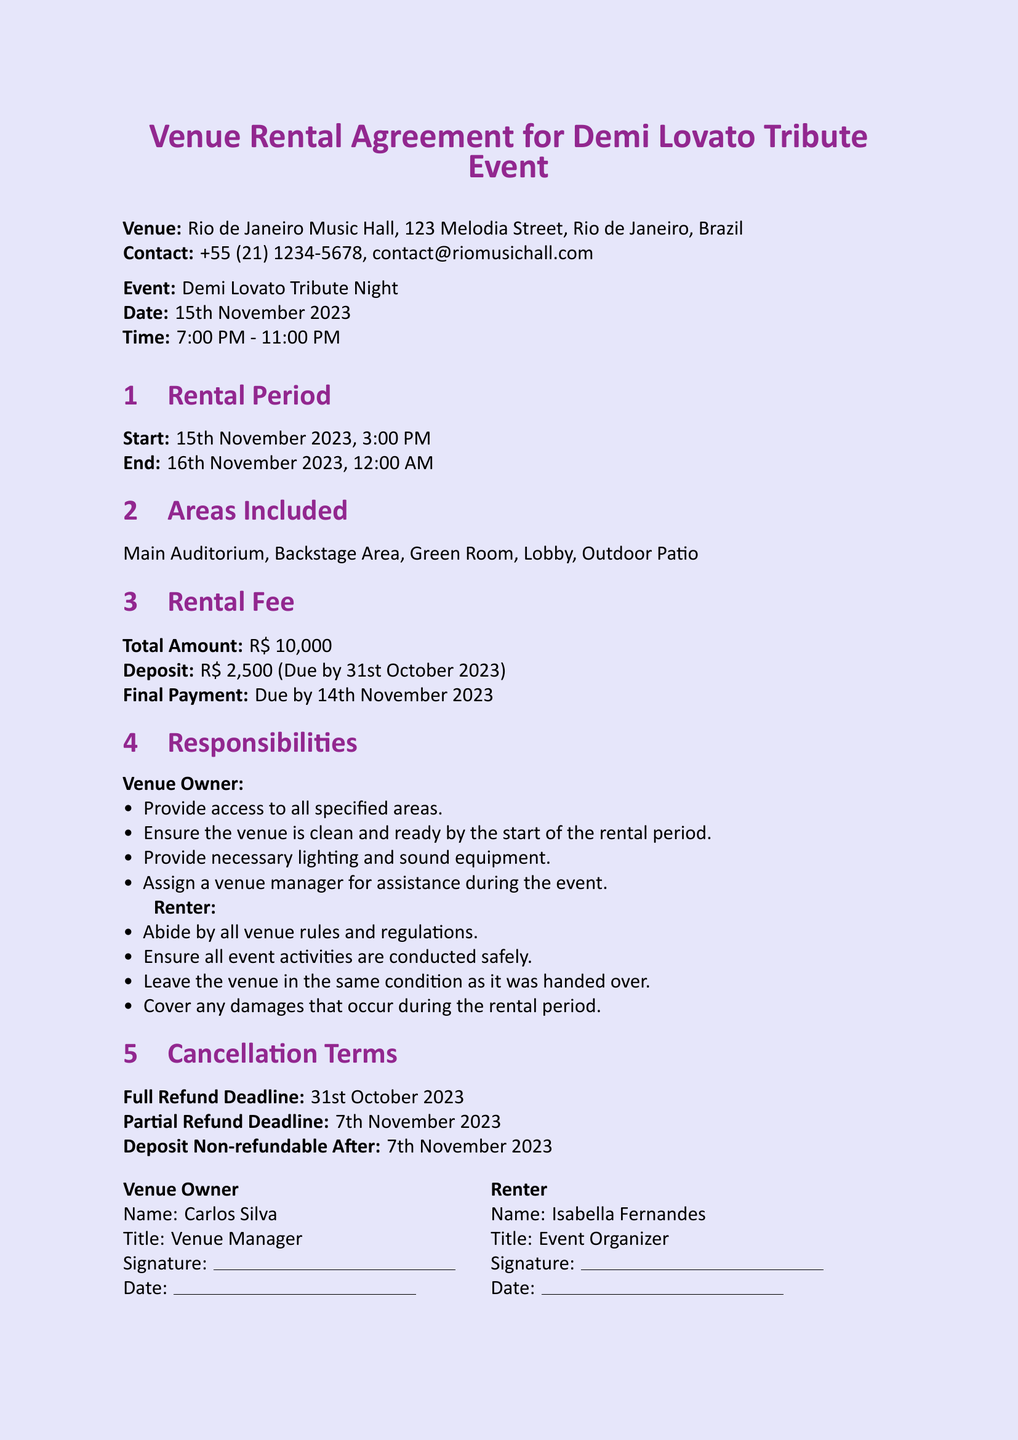What is the venue name? The venue name is the main location specified in the document for the event, which is Rio de Janeiro Music Hall.
Answer: Rio de Janeiro Music Hall What is the rental fee total amount? The total amount for the rental fee is explicitly stated in the document as part of the financial details.
Answer: R$ 10,000 What is the start time of the rental period? The start time of the rental period is detailed in the Rental Period section of the document.
Answer: 3:00 PM Who is the venue manager? The venue manager's name is provided in the signatures section of the document, representing the venue owner.
Answer: Carlos Silva What is the full refund deadline? The full refund deadline is mentioned under the Cancellation Terms section and indicates when a full refund can be requested.
Answer: 31st October 2023 What areas are included in the rental? The sections detail the areas available for use during the event rental, which are specified in a list format.
Answer: Main Auditorium, Backstage Area, Green Room, Lobby, Outdoor Patio What must the renter ensure regarding the venue condition? The responsibilities of the renter include leaving the venue in its original condition as stated in the responsibilities section.
Answer: Leave the venue in the same condition as it was handed over When is the final payment due? The final payment due date is mentioned as part of the financial obligations in the document.
Answer: 14th November 2023 